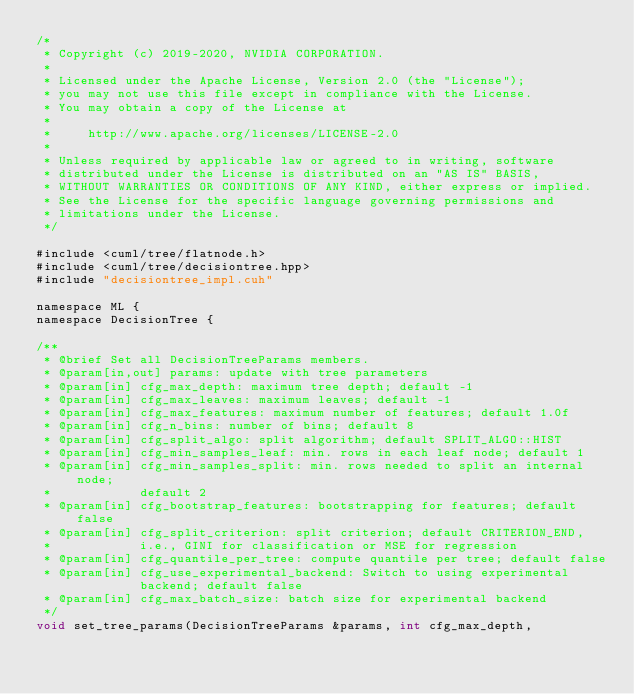Convert code to text. <code><loc_0><loc_0><loc_500><loc_500><_Cuda_>/*
 * Copyright (c) 2019-2020, NVIDIA CORPORATION.
 *
 * Licensed under the Apache License, Version 2.0 (the "License");
 * you may not use this file except in compliance with the License.
 * You may obtain a copy of the License at
 *
 *     http://www.apache.org/licenses/LICENSE-2.0
 *
 * Unless required by applicable law or agreed to in writing, software
 * distributed under the License is distributed on an "AS IS" BASIS,
 * WITHOUT WARRANTIES OR CONDITIONS OF ANY KIND, either express or implied.
 * See the License for the specific language governing permissions and
 * limitations under the License.
 */

#include <cuml/tree/flatnode.h>
#include <cuml/tree/decisiontree.hpp>
#include "decisiontree_impl.cuh"

namespace ML {
namespace DecisionTree {

/**
 * @brief Set all DecisionTreeParams members.
 * @param[in,out] params: update with tree parameters
 * @param[in] cfg_max_depth: maximum tree depth; default -1
 * @param[in] cfg_max_leaves: maximum leaves; default -1
 * @param[in] cfg_max_features: maximum number of features; default 1.0f
 * @param[in] cfg_n_bins: number of bins; default 8
 * @param[in] cfg_split_algo: split algorithm; default SPLIT_ALGO::HIST
 * @param[in] cfg_min_samples_leaf: min. rows in each leaf node; default 1
 * @param[in] cfg_min_samples_split: min. rows needed to split an internal node;
 *            default 2
 * @param[in] cfg_bootstrap_features: bootstrapping for features; default false
 * @param[in] cfg_split_criterion: split criterion; default CRITERION_END,
 *            i.e., GINI for classification or MSE for regression
 * @param[in] cfg_quantile_per_tree: compute quantile per tree; default false
 * @param[in] cfg_use_experimental_backend: Switch to using experimental
              backend; default false
 * @param[in] cfg_max_batch_size: batch size for experimental backend
 */
void set_tree_params(DecisionTreeParams &params, int cfg_max_depth,</code> 